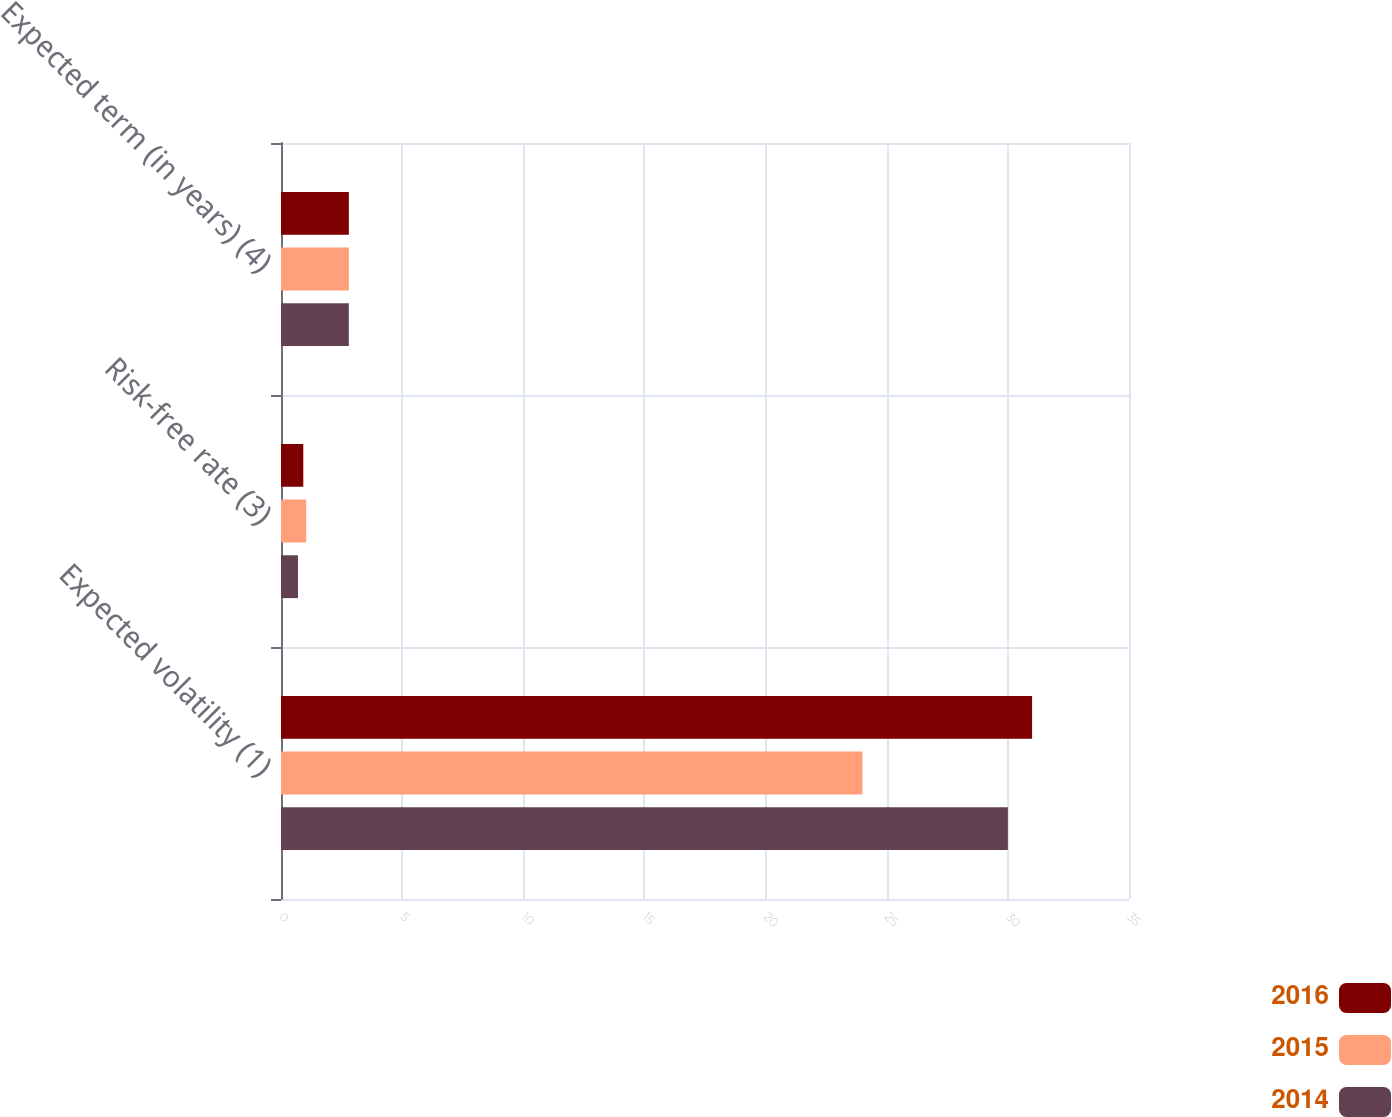Convert chart to OTSL. <chart><loc_0><loc_0><loc_500><loc_500><stacked_bar_chart><ecel><fcel>Expected volatility (1)<fcel>Risk-free rate (3)<fcel>Expected term (in years) (4)<nl><fcel>2016<fcel>31<fcel>0.92<fcel>2.8<nl><fcel>2015<fcel>24<fcel>1.04<fcel>2.8<nl><fcel>2014<fcel>30<fcel>0.7<fcel>2.8<nl></chart> 